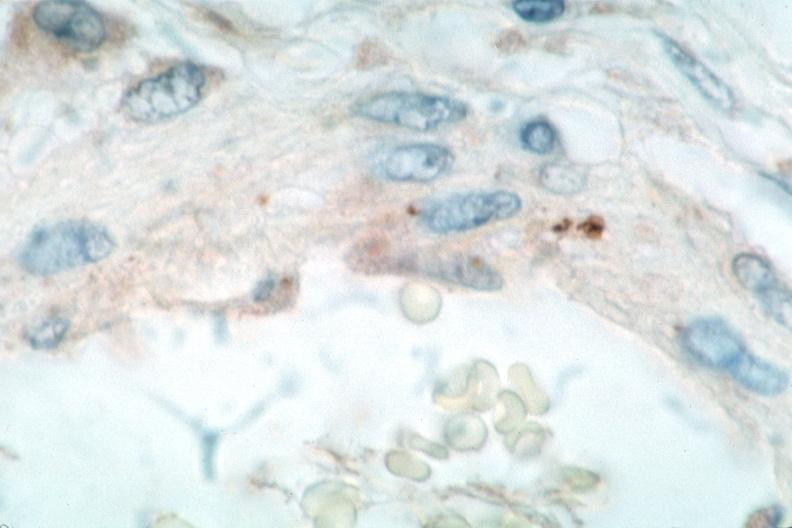s cardiovascular present?
Answer the question using a single word or phrase. Yes 